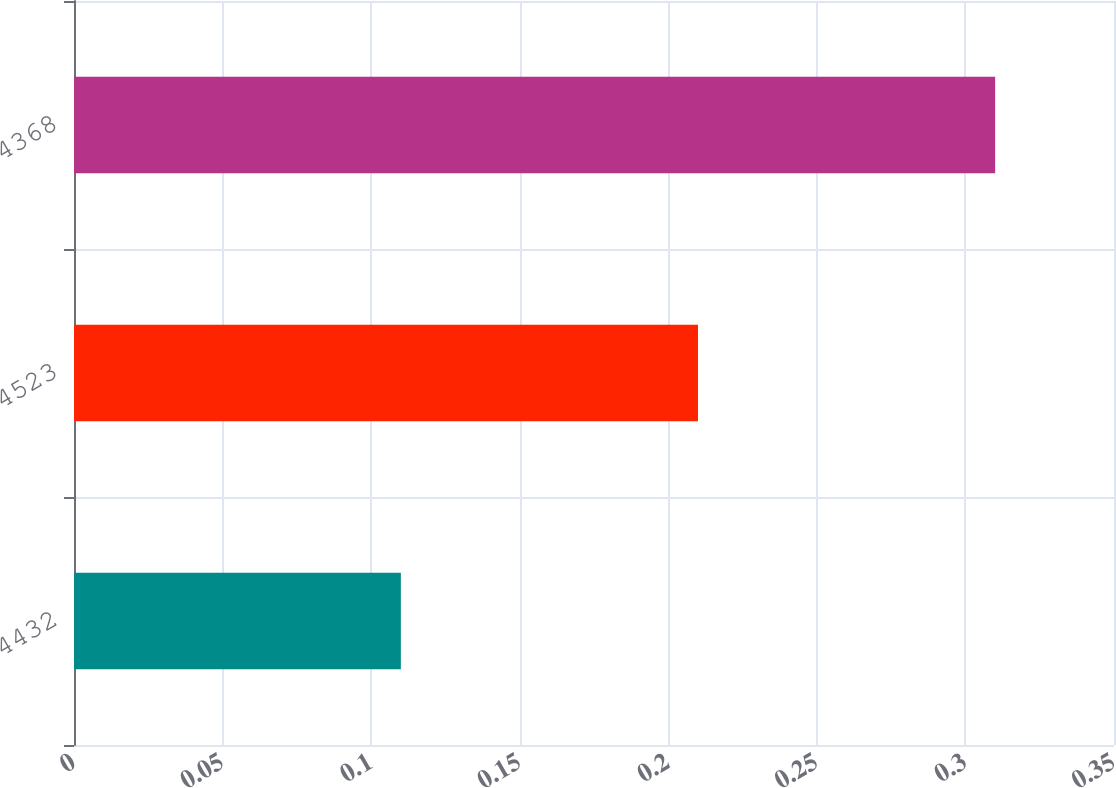Convert chart to OTSL. <chart><loc_0><loc_0><loc_500><loc_500><bar_chart><fcel>4432<fcel>4523<fcel>4368<nl><fcel>0.11<fcel>0.21<fcel>0.31<nl></chart> 